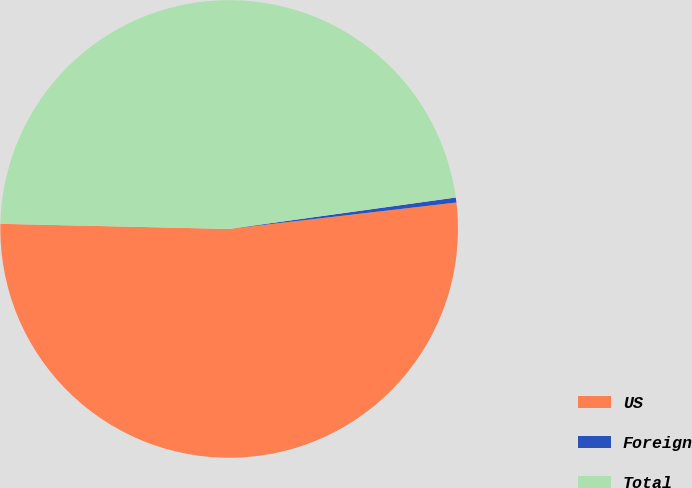<chart> <loc_0><loc_0><loc_500><loc_500><pie_chart><fcel>US<fcel>Foreign<fcel>Total<nl><fcel>52.2%<fcel>0.35%<fcel>47.45%<nl></chart> 